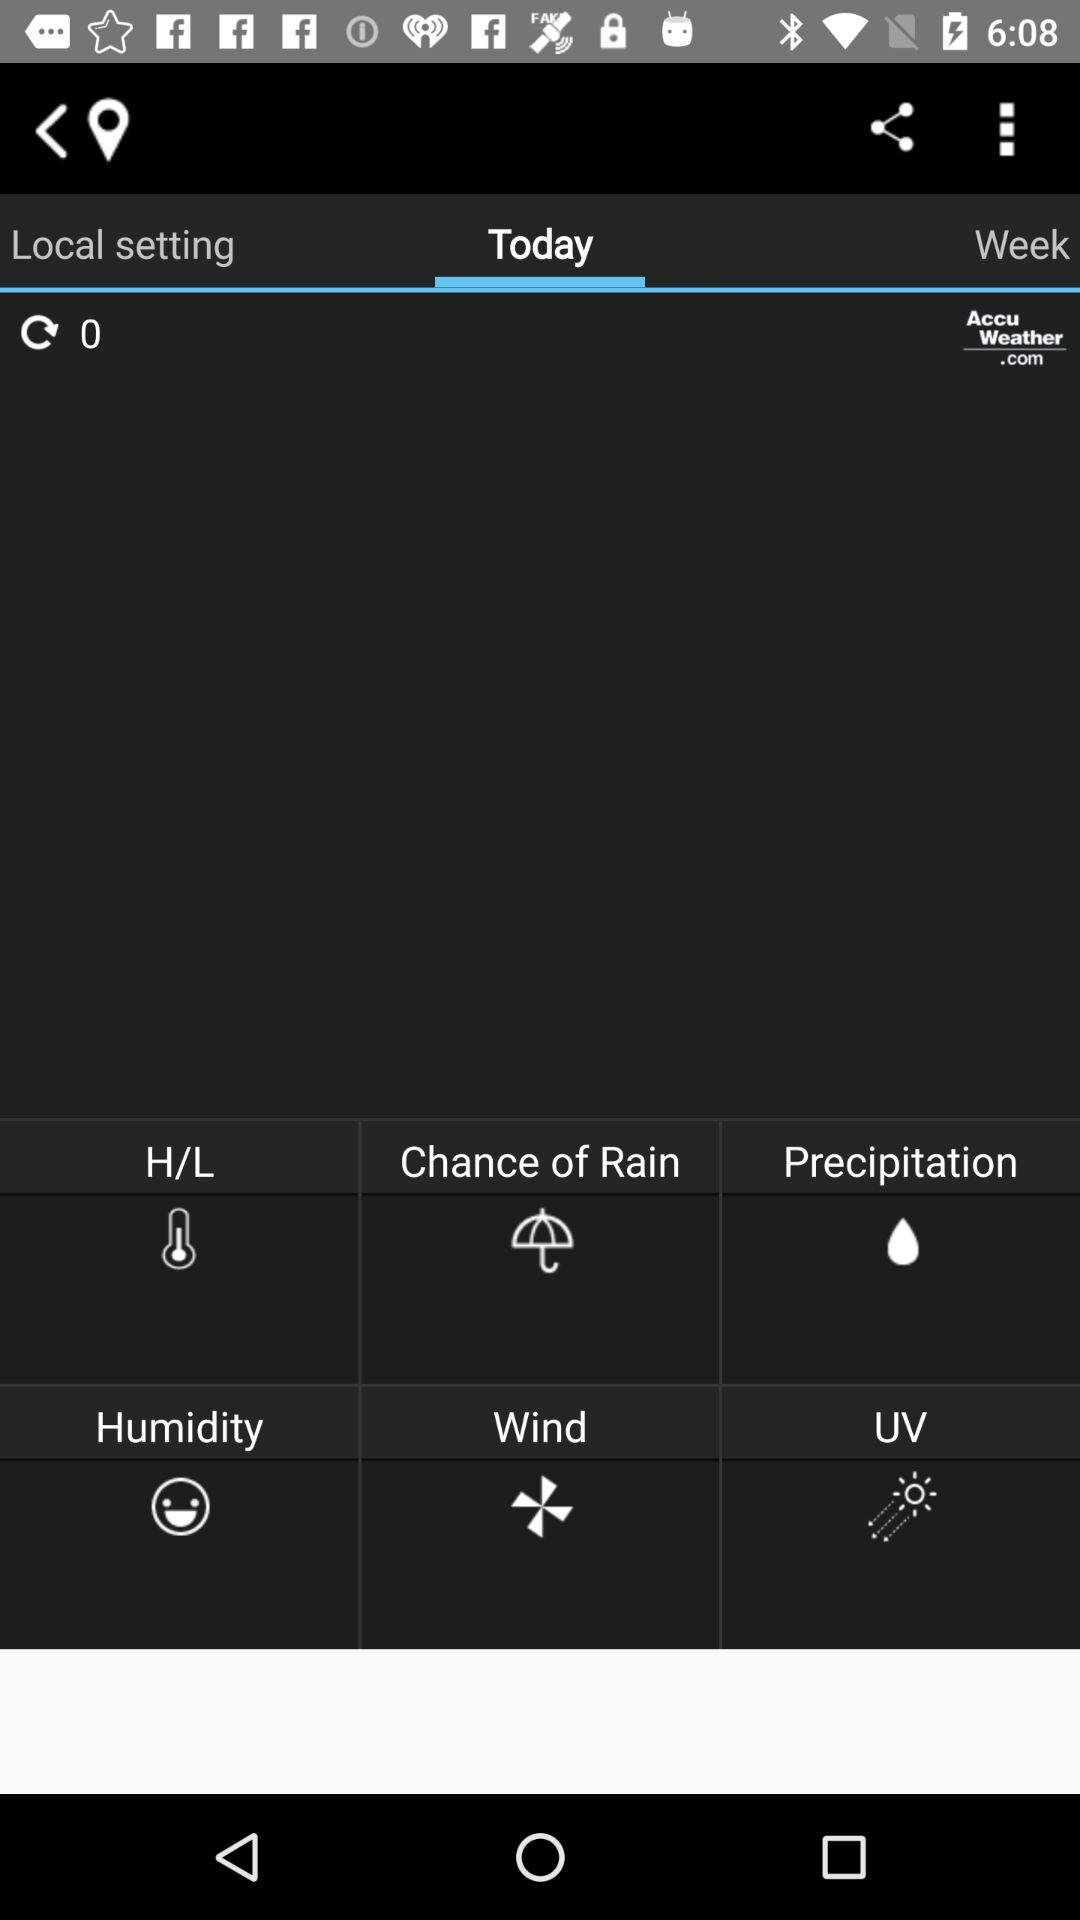Which tab is selected? The selected tab is "Today". 